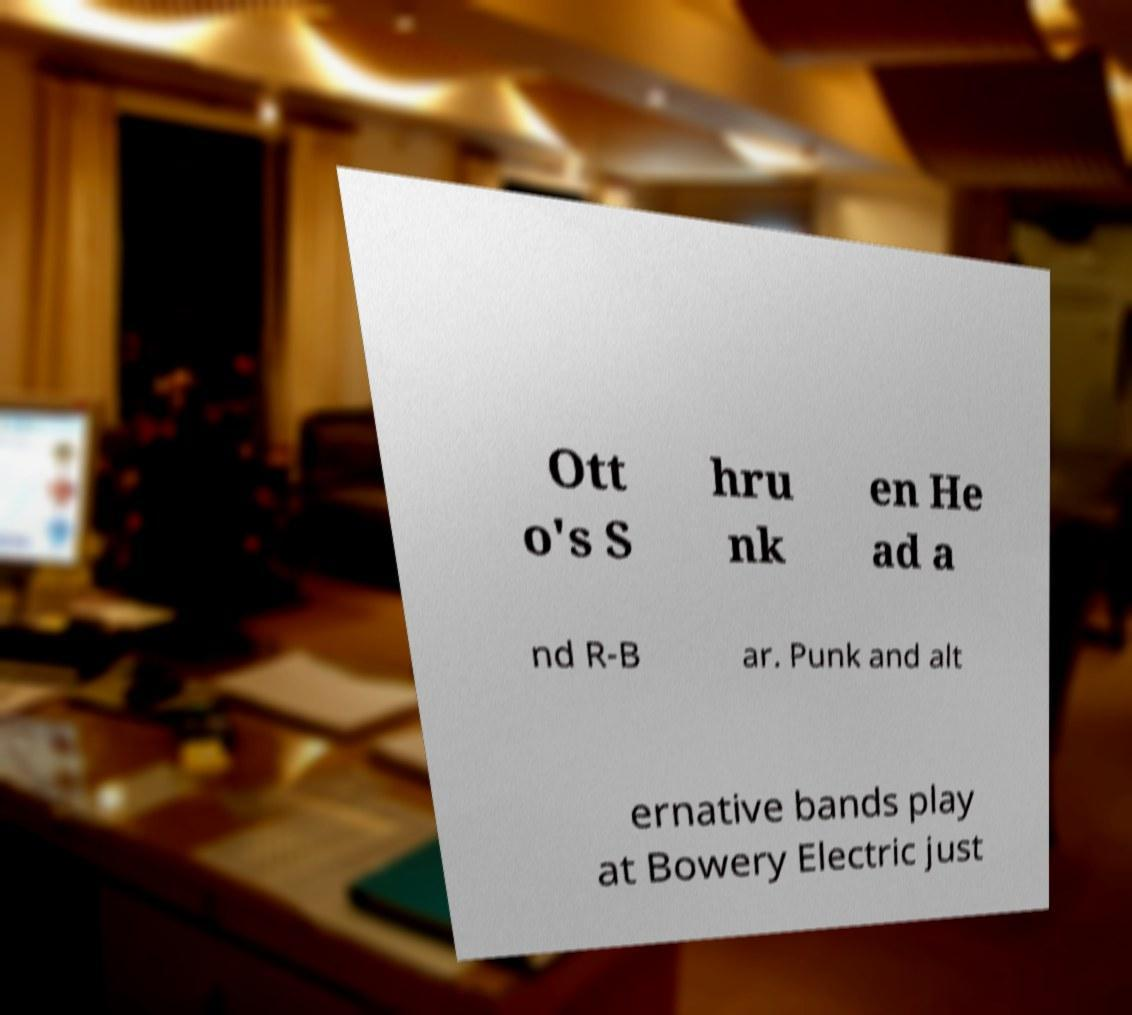Can you accurately transcribe the text from the provided image for me? Ott o's S hru nk en He ad a nd R-B ar. Punk and alt ernative bands play at Bowery Electric just 